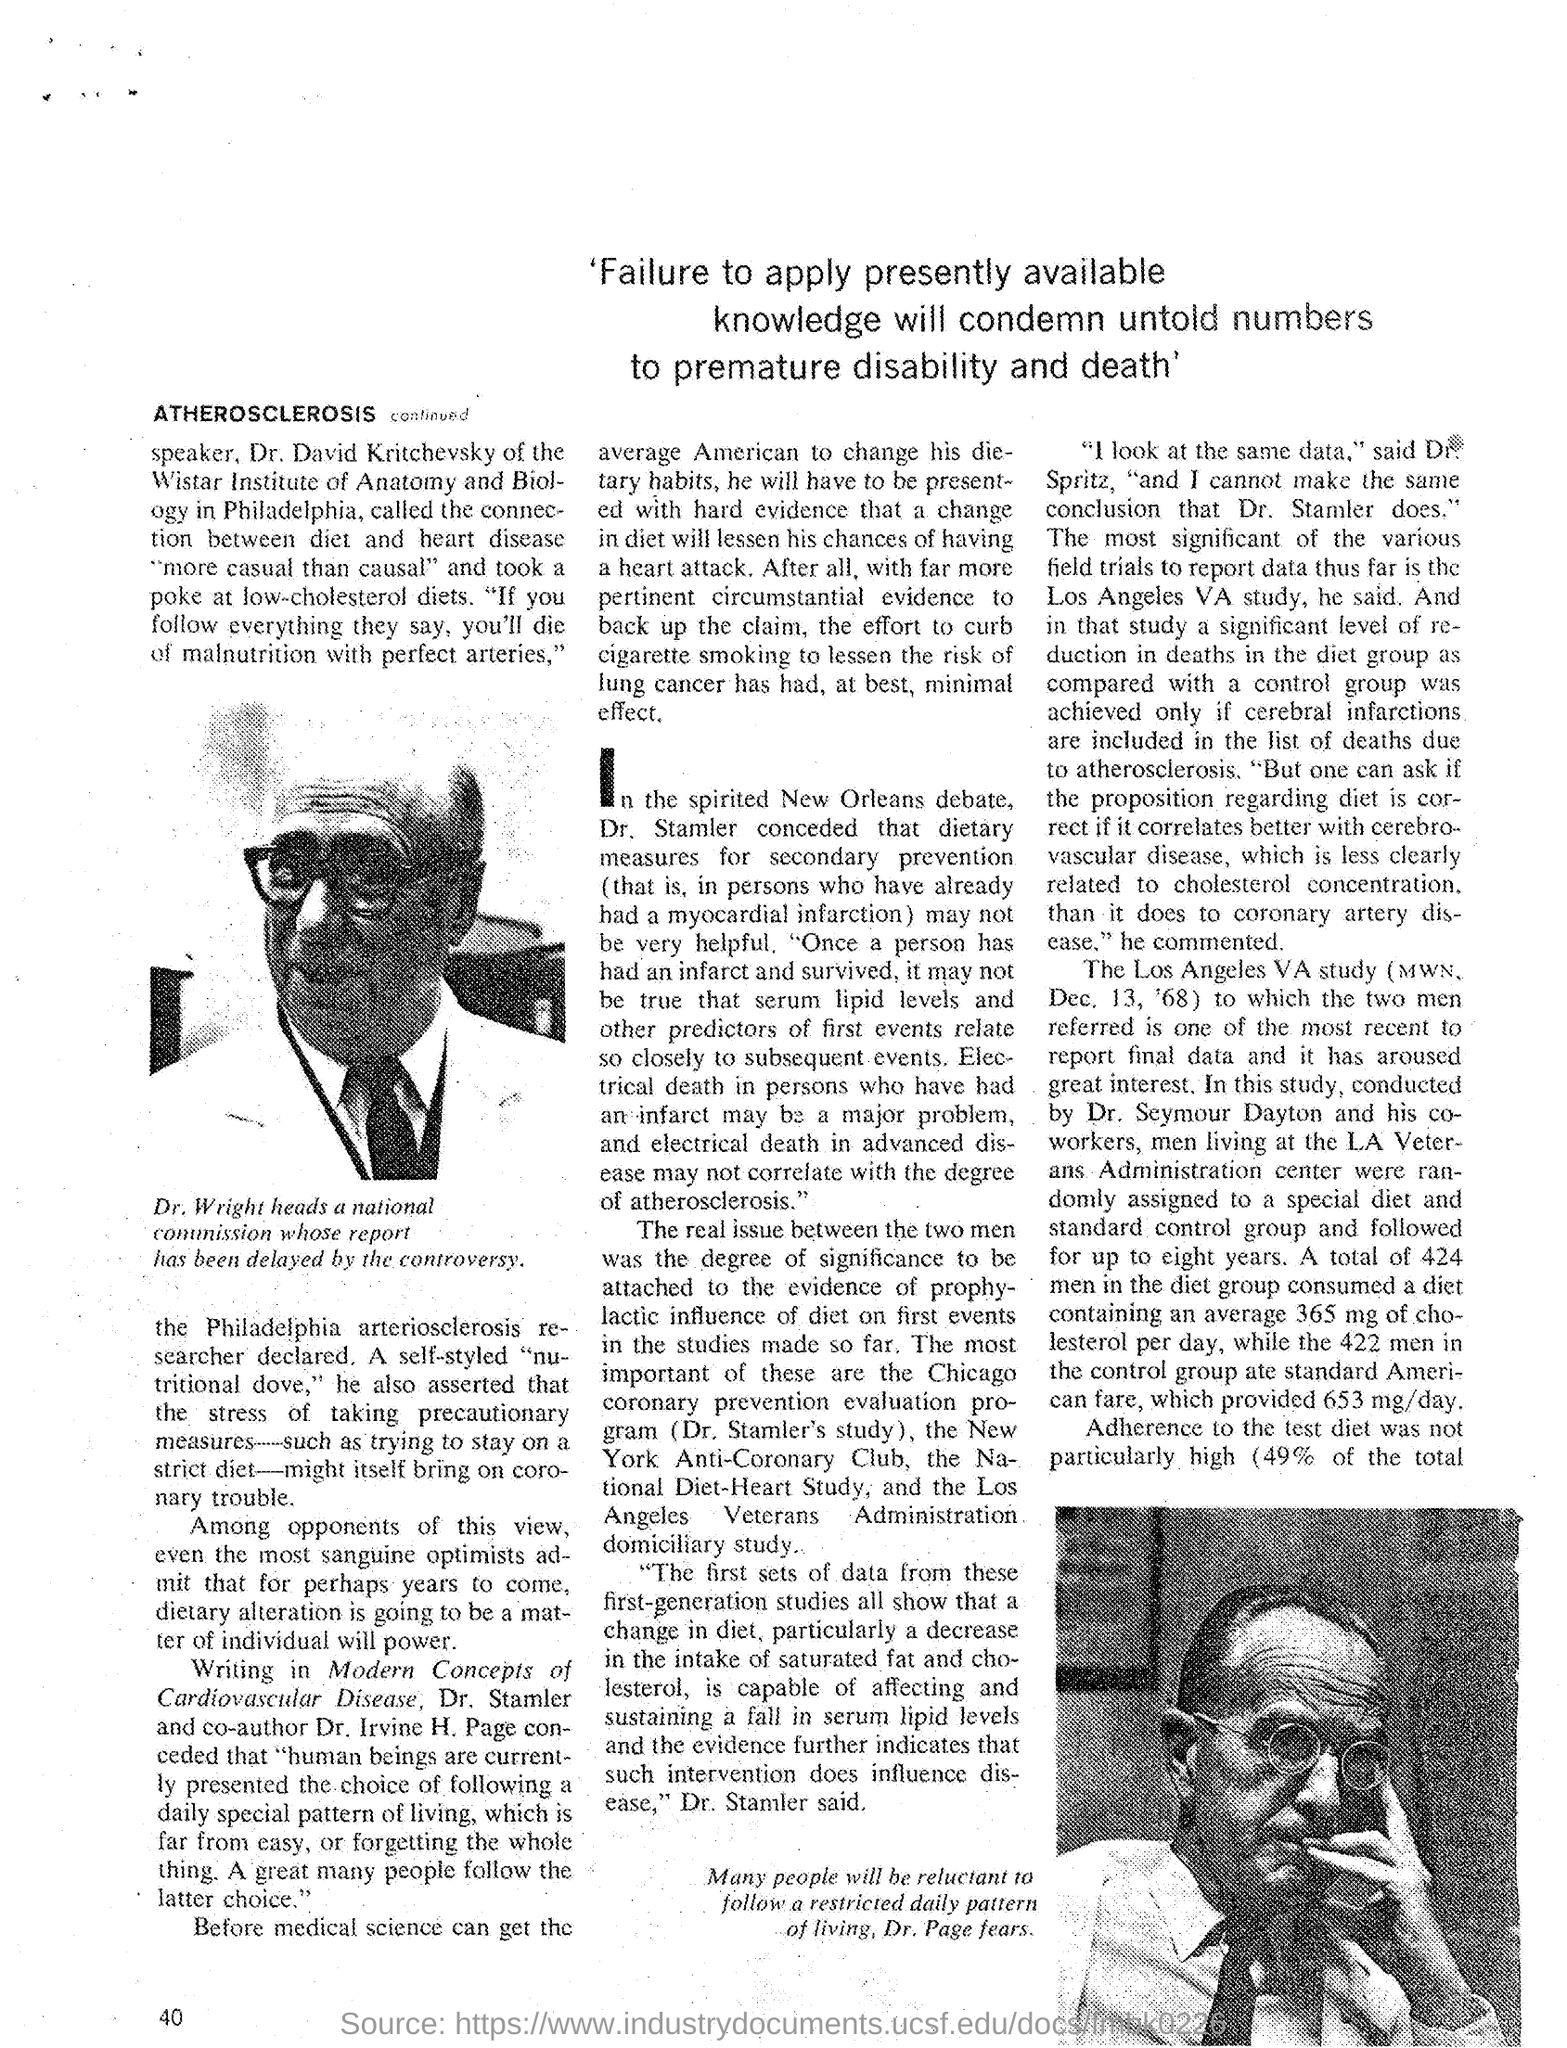Where is Wistar Institute of Anatomy and Biology located?
Your answer should be very brief. Philadelphia. 